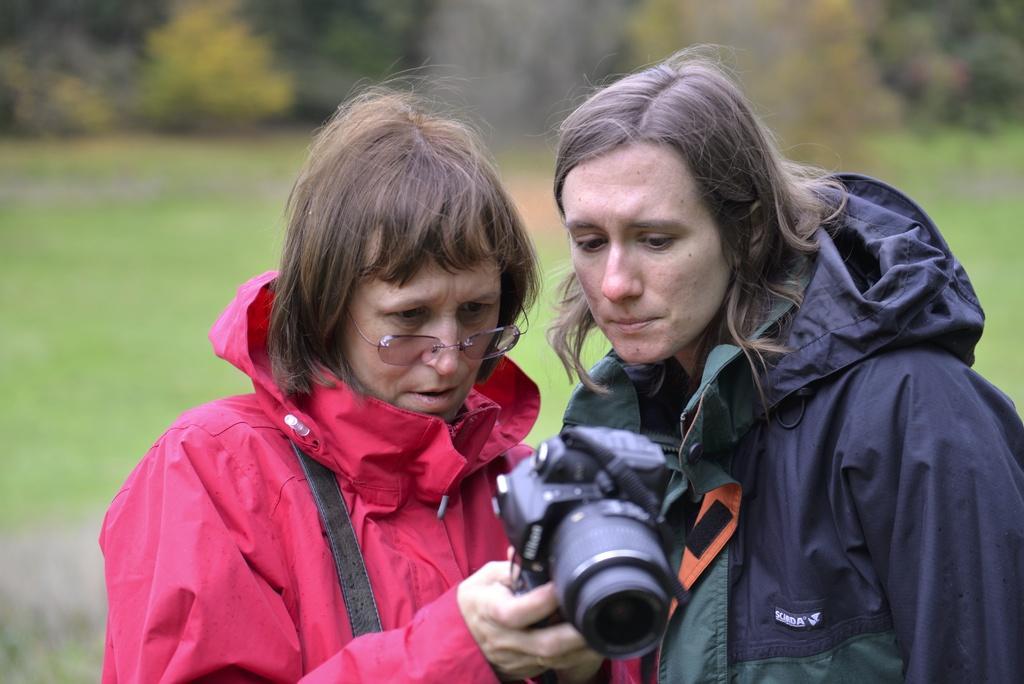Please provide a concise description of this image. In this picture there are two women standing. A woman in pink jacket is holding a camera in her hand. There is some grass on the ground and few plants at the background. 